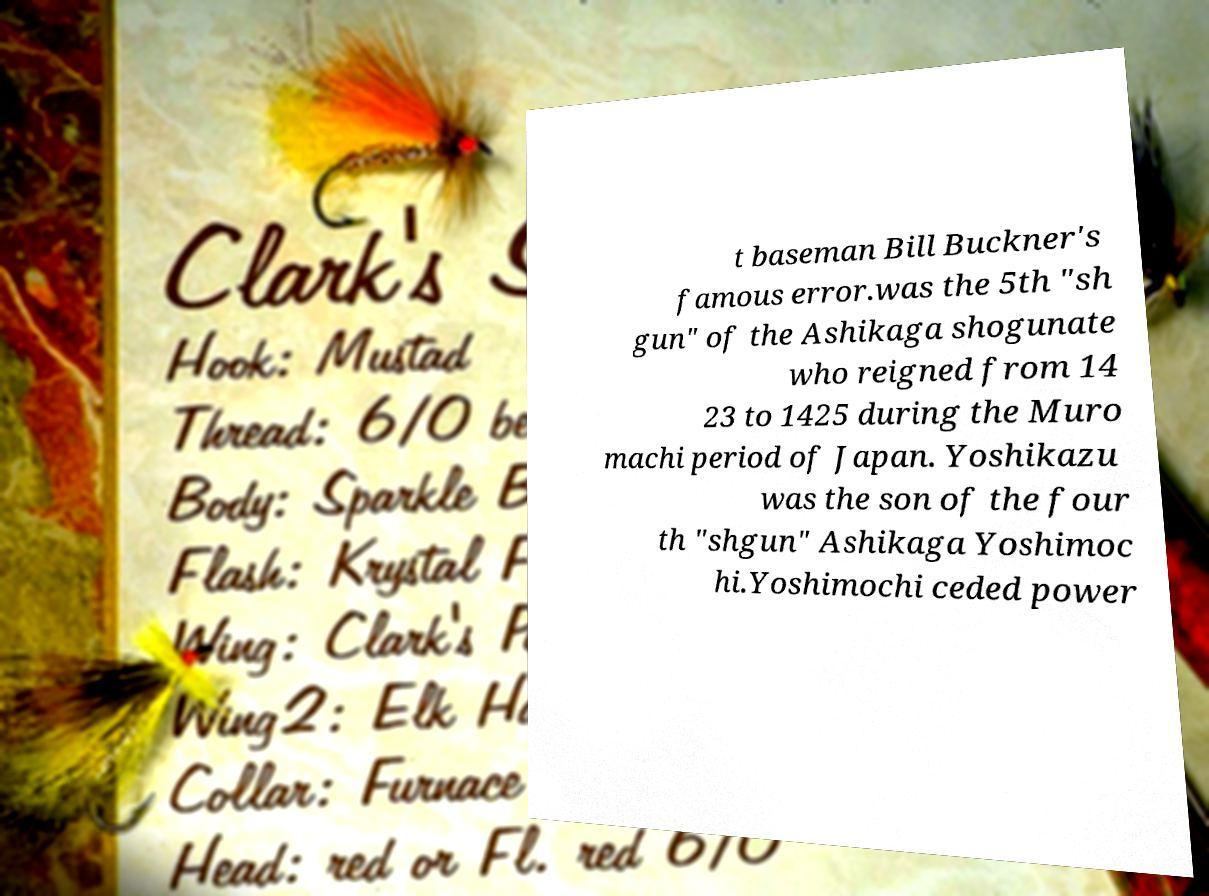Could you extract and type out the text from this image? t baseman Bill Buckner's famous error.was the 5th "sh gun" of the Ashikaga shogunate who reigned from 14 23 to 1425 during the Muro machi period of Japan. Yoshikazu was the son of the four th "shgun" Ashikaga Yoshimoc hi.Yoshimochi ceded power 